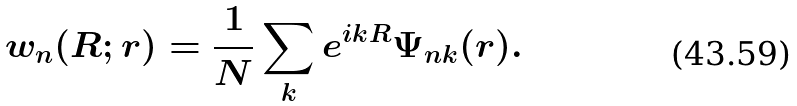Convert formula to latex. <formula><loc_0><loc_0><loc_500><loc_500>w _ { n } ( { R } ; { r } ) = \frac { 1 } { N } \sum _ { k } e ^ { i { k R } } \Psi _ { n { k } } ( { r } ) .</formula> 